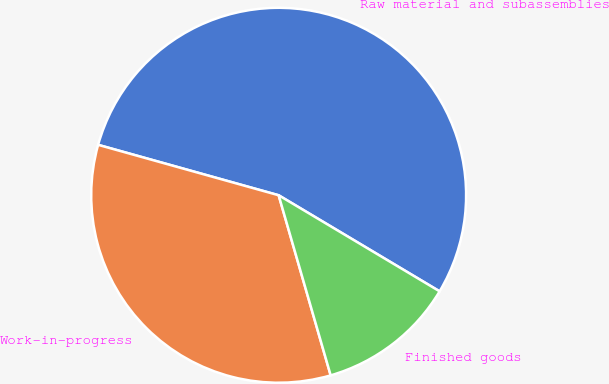Convert chart to OTSL. <chart><loc_0><loc_0><loc_500><loc_500><pie_chart><fcel>Raw material and subassemblies<fcel>Work-in-progress<fcel>Finished goods<nl><fcel>54.23%<fcel>33.81%<fcel>11.96%<nl></chart> 